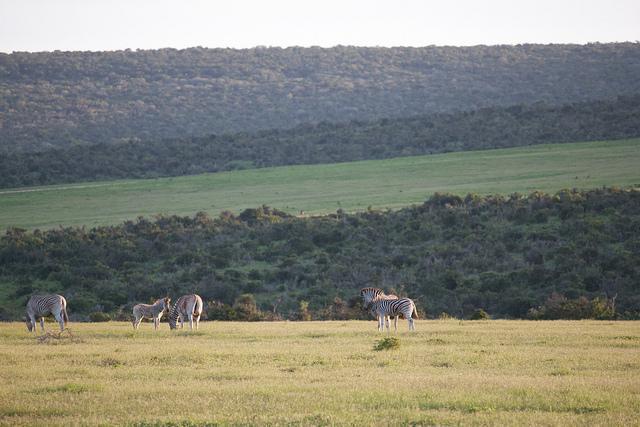What are the zebras looking at on the grass?
Select the accurate answer and provide explanation: 'Answer: answer
Rationale: rationale.'
Options: Strangers, food, mountains, friends. Answer: food.
Rationale: The zebras are looking down at the grass for food. How many zebras are sitting atop of the grassy field?
Indicate the correct response by choosing from the four available options to answer the question.
Options: One, four, three, two. Four. 